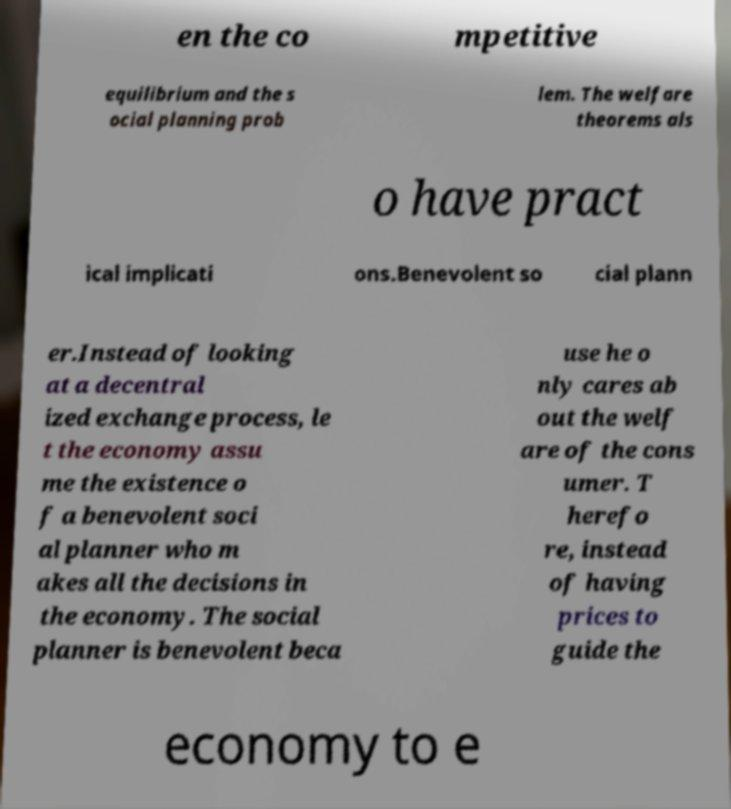Please identify and transcribe the text found in this image. en the co mpetitive equilibrium and the s ocial planning prob lem. The welfare theorems als o have pract ical implicati ons.Benevolent so cial plann er.Instead of looking at a decentral ized exchange process, le t the economy assu me the existence o f a benevolent soci al planner who m akes all the decisions in the economy. The social planner is benevolent beca use he o nly cares ab out the welf are of the cons umer. T herefo re, instead of having prices to guide the economy to e 